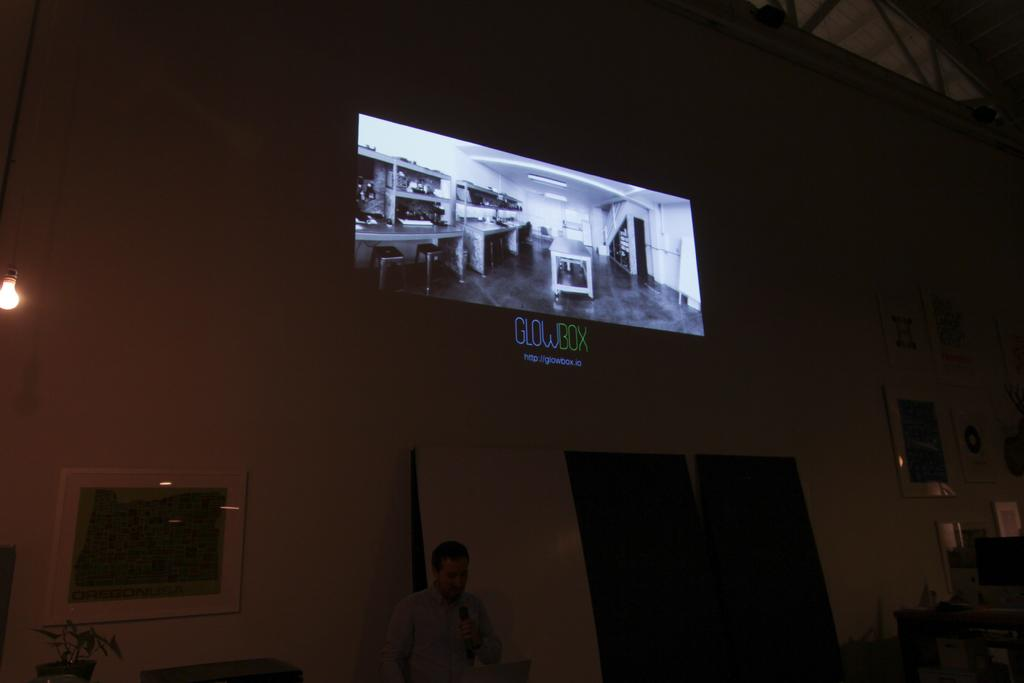What is the person in the image doing? The person is standing in the image and holding a mic in their hands. What can be seen on the walls in the image? Wall hangings are attached to the wall in the image. What type of vegetation is present in the image? There are houseplants in the image. What type of lighting is visible in the image? An electric bulb is visible in the image. What device is present in the image for displaying information? A display screen is present in the image. What type of berry is being used as a microphone stand in the image? There is no berry being used as a microphone stand in the image; the person is holding the mic in their hands. What type of celery is being used as a wall hanging in the image? There is no celery being used as a wall hanging in the image; the wall hangings are separate from the houseplants. 